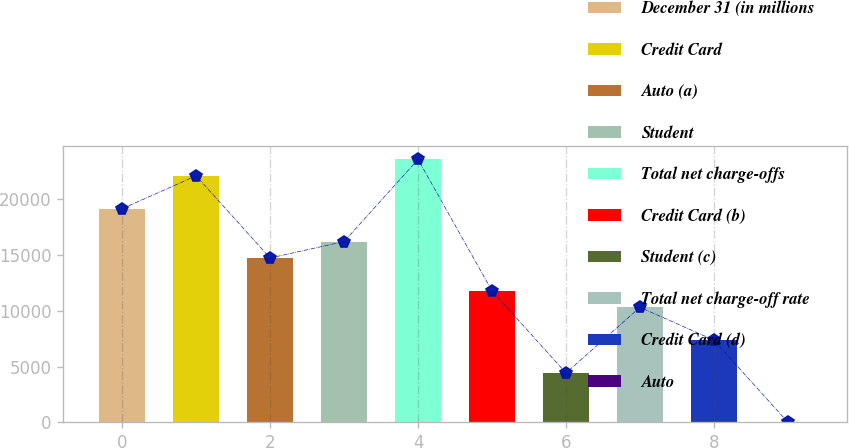Convert chart to OTSL. <chart><loc_0><loc_0><loc_500><loc_500><bar_chart><fcel>December 31 (in millions<fcel>Credit Card<fcel>Auto (a)<fcel>Student<fcel>Total net charge-offs<fcel>Credit Card (b)<fcel>Student (c)<fcel>Total net charge-off rate<fcel>Credit Card (d)<fcel>Auto<nl><fcel>19138.3<fcel>22082.4<fcel>14722<fcel>16194.1<fcel>23554.5<fcel>11777.9<fcel>4417.46<fcel>10305.8<fcel>7361.62<fcel>1.22<nl></chart> 